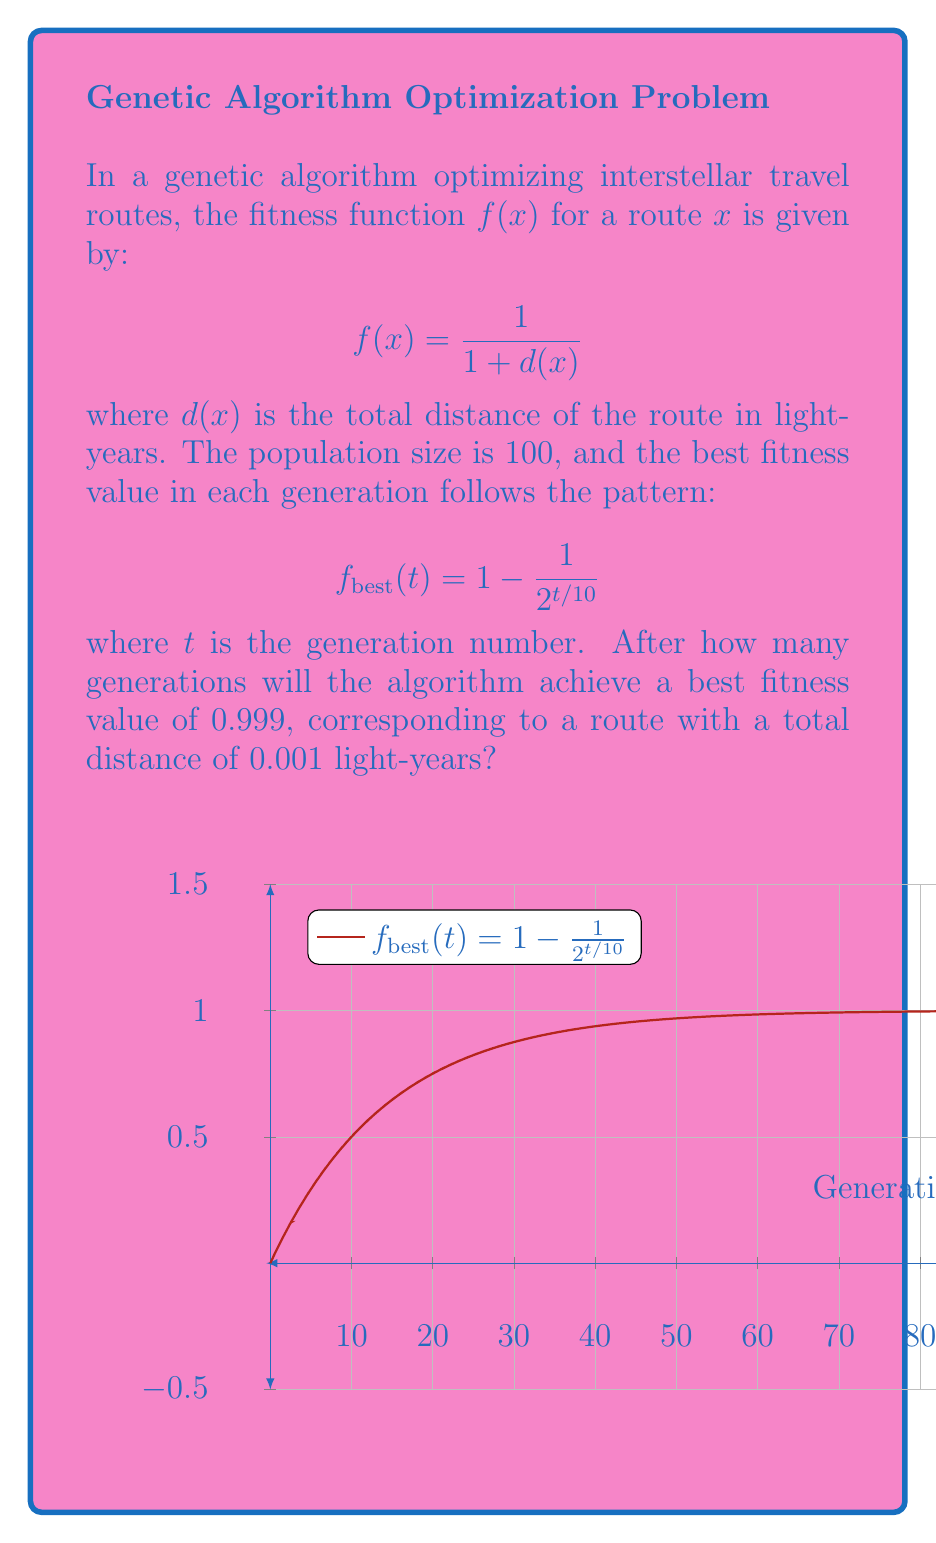What is the answer to this math problem? To solve this problem, we need to follow these steps:

1) We want to find $t$ when $f_{best}(t) = 0.999$. So, we need to solve the equation:

   $$0.999 = 1 - \frac{1}{2^{t/10}}$$

2) Subtracting both sides from 1:

   $$0.001 = \frac{1}{2^{t/10}}$$

3) Taking the reciprocal of both sides:

   $$1000 = 2^{t/10}$$

4) Taking the logarithm (base 2) of both sides:

   $$\log_2(1000) = \frac{t}{10}$$

5) Multiplying both sides by 10:

   $$10 \log_2(1000) = t$$

6) Calculate the value:

   $$t = 10 \log_2(1000) \approx 99.66$$

7) Since we need a whole number of generations, we round up to the next integer:

   $$t = 100$$

Therefore, it will take 100 generations to achieve a best fitness value of 0.999, corresponding to a route with a total distance of 0.001 light-years.
Answer: 100 generations 